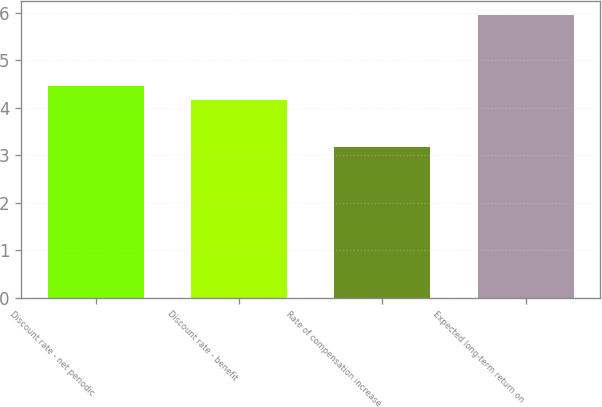<chart> <loc_0><loc_0><loc_500><loc_500><bar_chart><fcel>Discount rate - net periodic<fcel>Discount rate - benefit<fcel>Rate of compensation increase<fcel>Expected long-term return on<nl><fcel>4.45<fcel>4.17<fcel>3.17<fcel>5.95<nl></chart> 